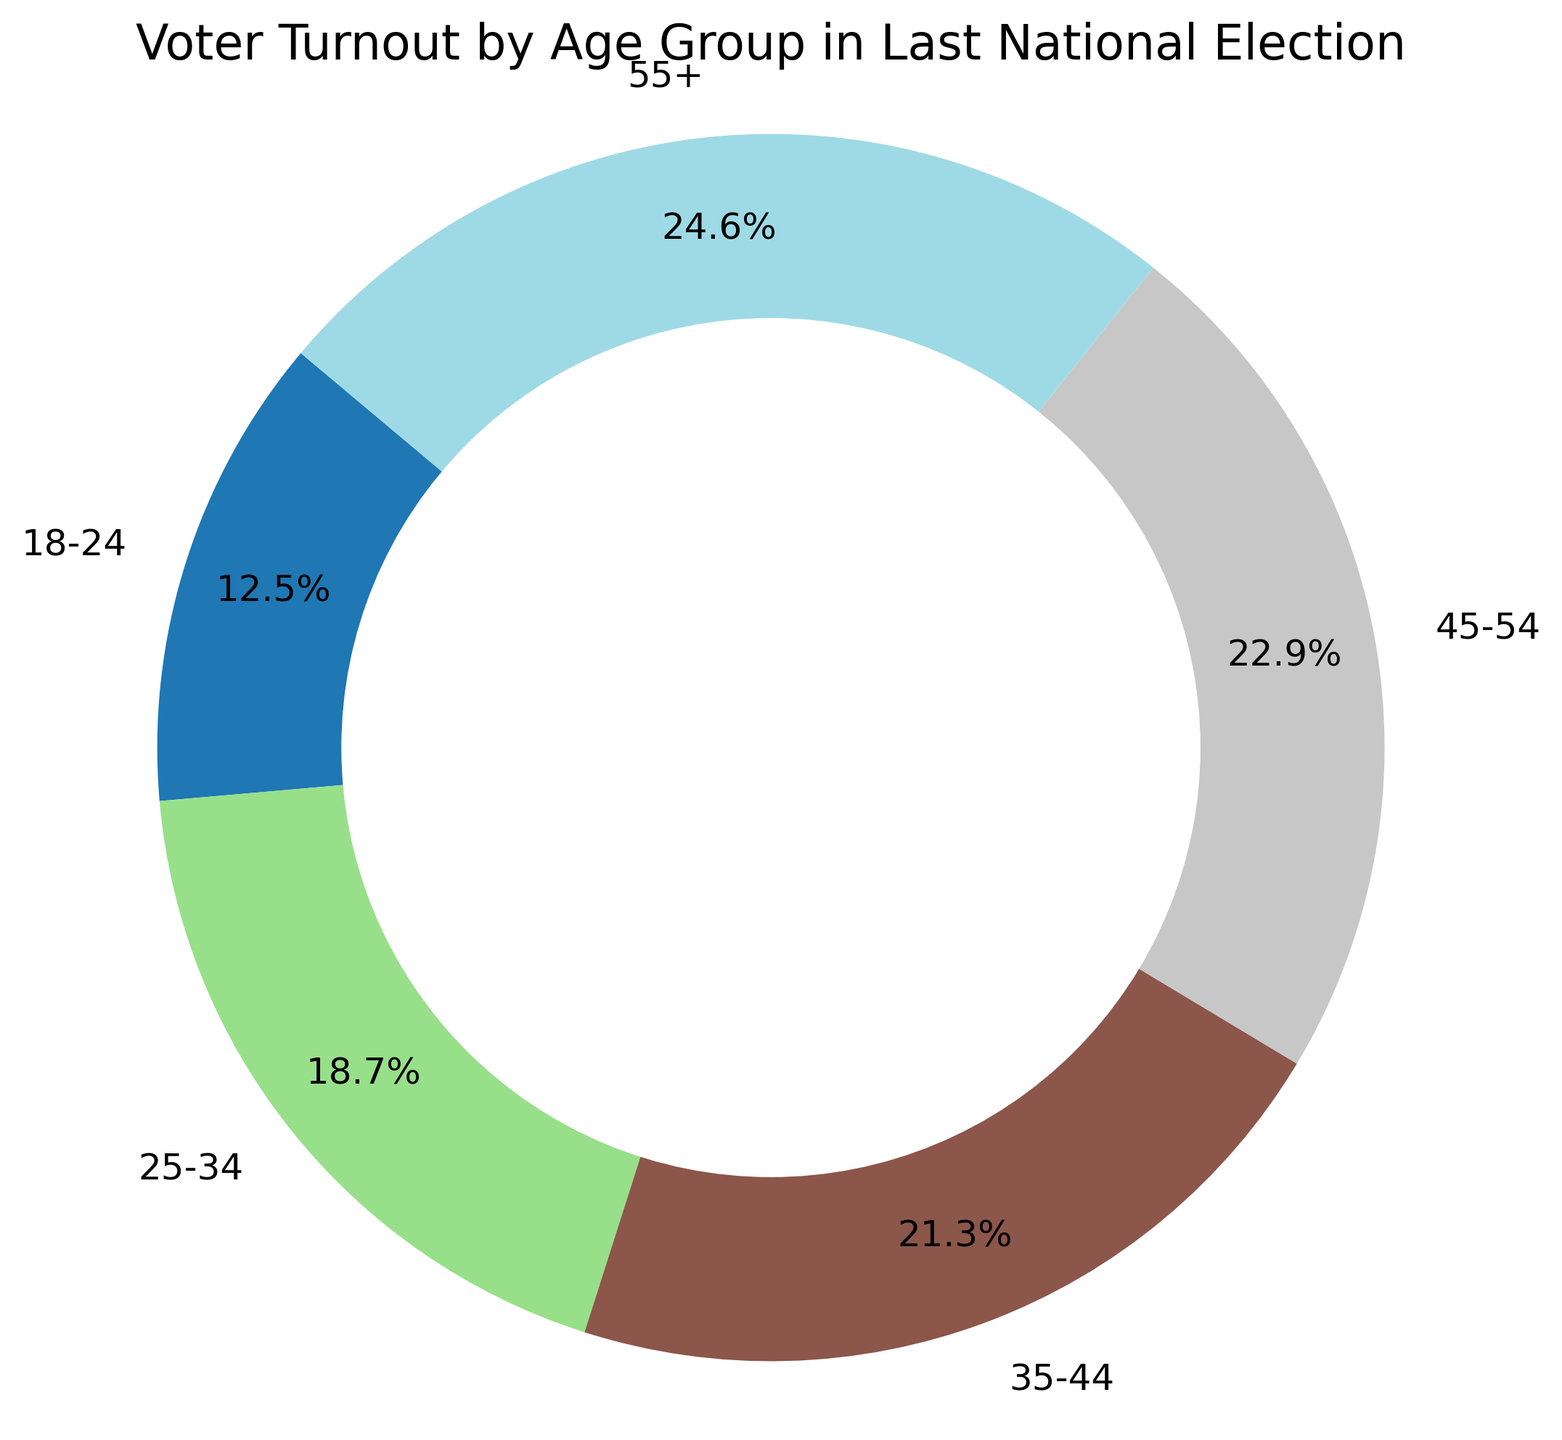Which age group has the highest voter turnout percentage? By examining the pie chart, it is clear that the 55+ age group has the largest slice, indicating the highest voter turnout percentage at 24.6%.
Answer: 55+ Which age group has the lowest voter turnout percentage? The pie chart shows that the 18-24 age group has the smallest slice, indicating the lowest voter turnout percentage at 12.5%.
Answer: 18-24 What is the total percentage of voter turnout for age groups 18-34 combined? To find this, sum the percentages of the 18-24 and 25-34 age groups: 12.5% + 18.7% = 31.2%.
Answer: 31.2% How much higher is the voter turnout percentage of the 45-54 age group compared to the 18-24 age group? Subtract the voter turnout percentage of the 18-24 age group (12.5%) from the 45-54 age group (22.9%): 22.9% - 12.5% = 10.4%.
Answer: 10.4% What is the average voter turnout percentage across all age groups? Sum the voter turnout percentages of all age groups and divide by the number of age groups: (12.5% + 18.7% + 21.3% + 22.9% + 24.6%) / 5 = 20%.
Answer: 20% Which age groups have a voter turnout percentage above 20%? By examining the pie chart, the age groups 35-44 (21.3%), 45-54 (22.9%), and 55+ (24.6%) have voter turnout percentages above 20%.
Answer: 35-44, 45-54, 55+ How does the voter turnout of the 25-34 age group compare to the 35-44 age group? The voter turnout percentage of the 25-34 age group is 18.7%, while the 35-44 age group has a percentage of 21.3%, making the 35-44 age group's turnout higher.
Answer: 35-44 age group's turnout is higher What is the difference between the voter turnout percentages of the age groups with the highest and lowest turnouts? Subtract the voter turnout percentage of the age group with the lowest turnout (18-24: 12.5%) from the age group with the highest turnout (55+: 24.6%): 24.6% - 12.5% = 12.1%.
Answer: 12.1% What percentage of total voter turnout is contributed by age groups 35-54? Sum the voter turnout percentages of the 35-44 and 45-54 age groups: 21.3% + 22.9% = 44.2%.
Answer: 44.2% Which color represents the 18-24 age group? By examining the pie chart, the color representing the 18-24 age group can be identified visually. (Note: Actual color cannot be described here without the visual). Typically, distinguishable colors are used for each slice in a pie chart; the exact color is identified visually.
Answer: (Visual identification) 